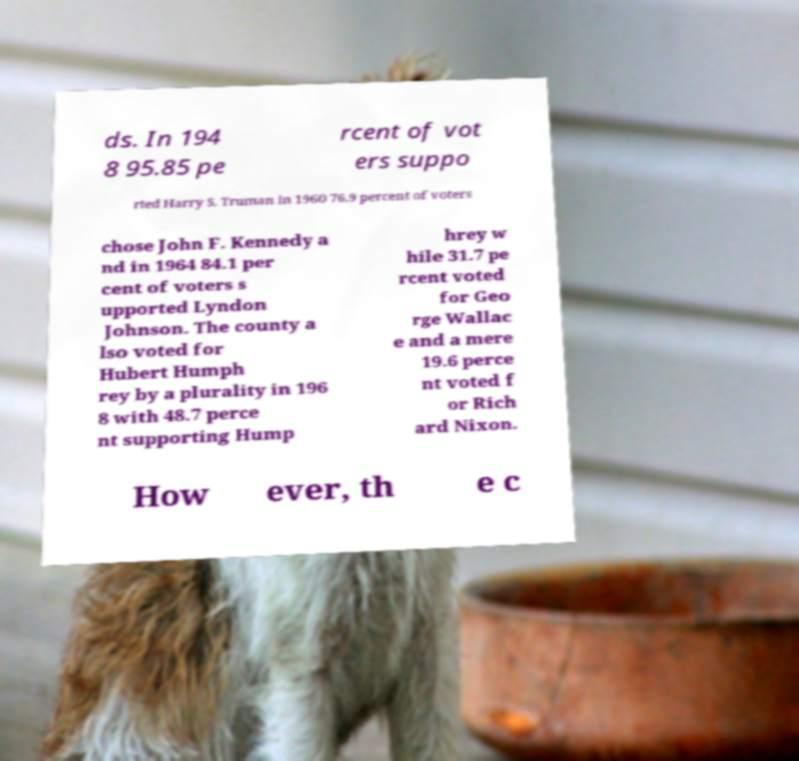Could you extract and type out the text from this image? ds. In 194 8 95.85 pe rcent of vot ers suppo rted Harry S. Truman in 1960 76.9 percent of voters chose John F. Kennedy a nd in 1964 84.1 per cent of voters s upported Lyndon Johnson. The county a lso voted for Hubert Humph rey by a plurality in 196 8 with 48.7 perce nt supporting Hump hrey w hile 31.7 pe rcent voted for Geo rge Wallac e and a mere 19.6 perce nt voted f or Rich ard Nixon. How ever, th e c 